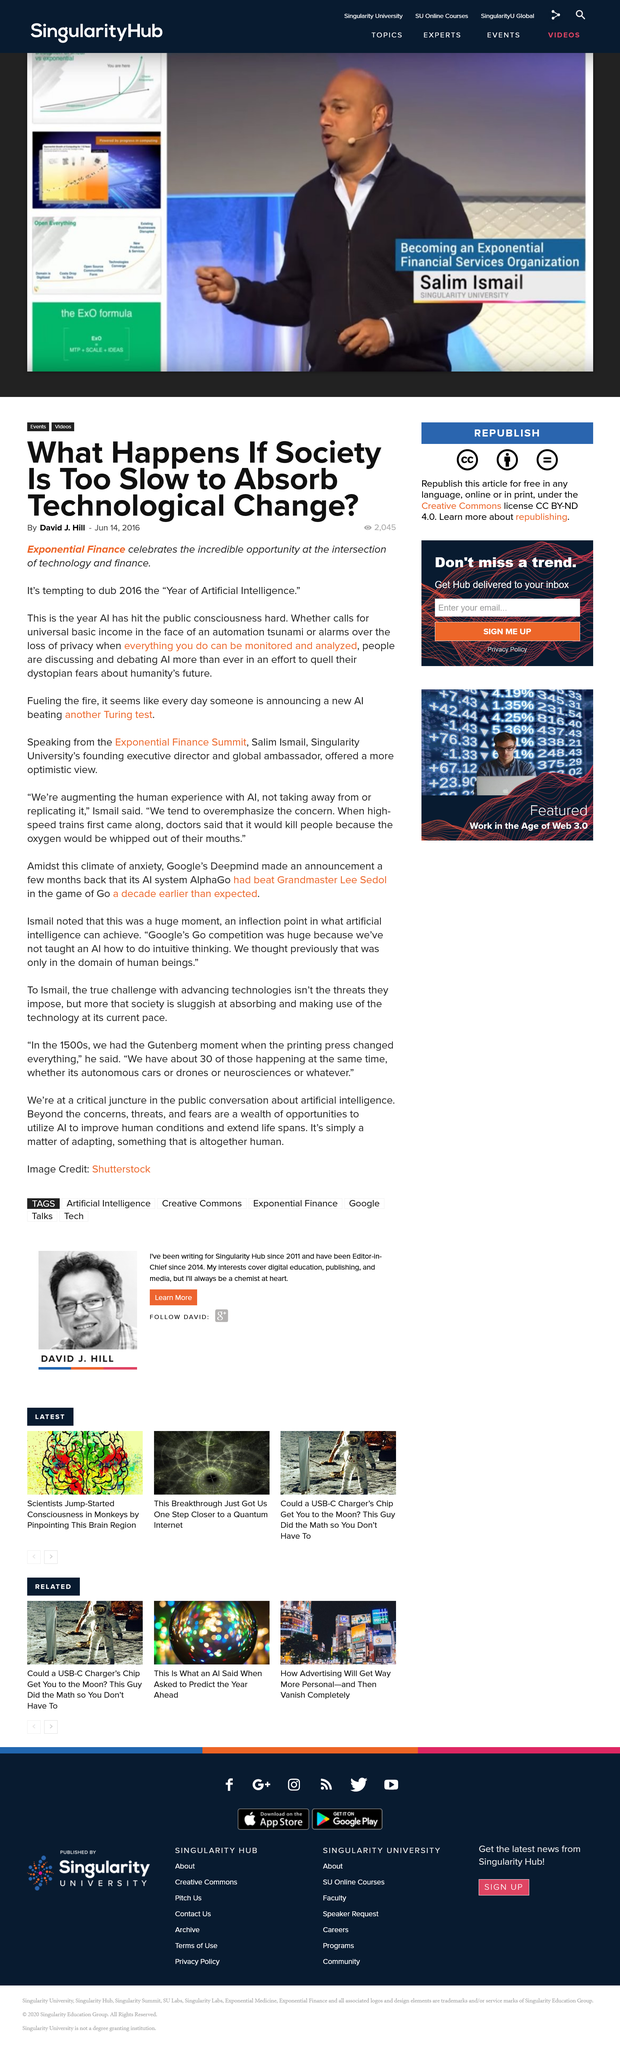Give some essential details in this illustration. The author of the article is David J. Hill. The title of this text is 'What is the name of the title? What happens if society is too slow to absorb technology change?' I am unable to complete your request as it is currently phrased. Could you please provide more context or clarify your request? 